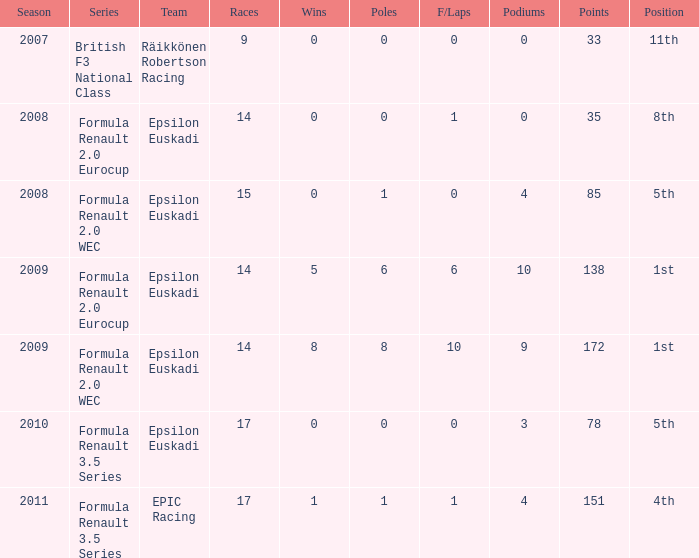How many f/laps when he finished 8th? 1.0. 